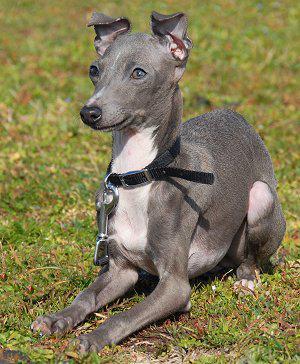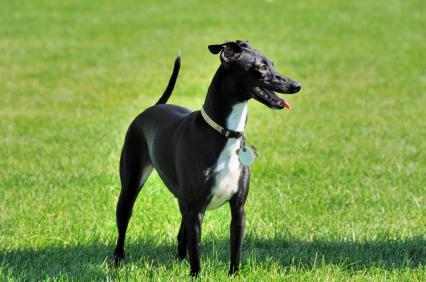The first image is the image on the left, the second image is the image on the right. Analyze the images presented: Is the assertion "Exactly one of the dogs is lying down." valid? Answer yes or no. Yes. The first image is the image on the left, the second image is the image on the right. For the images shown, is this caption "An image shows a two-color dog sitting upright with its eyes on the camera." true? Answer yes or no. No. 